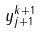Convert formula to latex. <formula><loc_0><loc_0><loc_500><loc_500>y _ { j + 1 } ^ { k + 1 }</formula> 